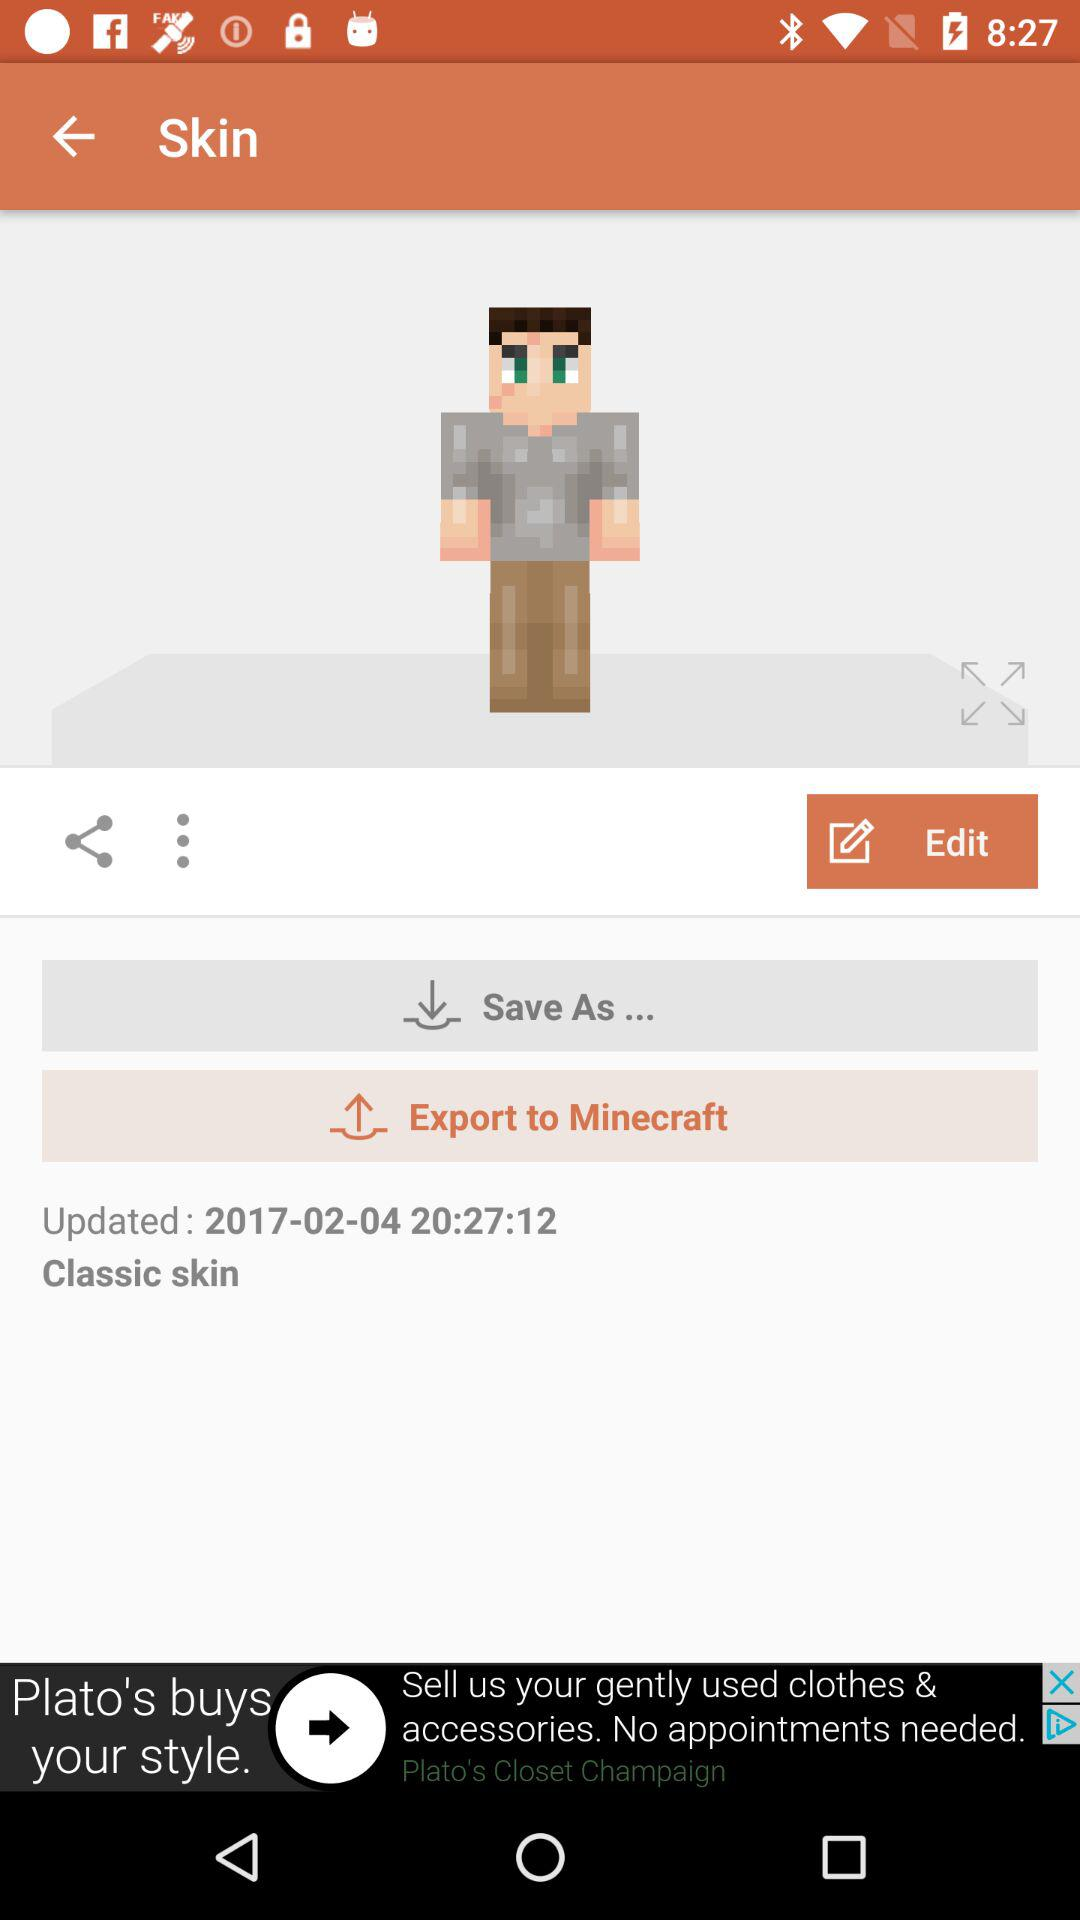What date was the skin last updated? The skin was last updated on February 4, 2017. 